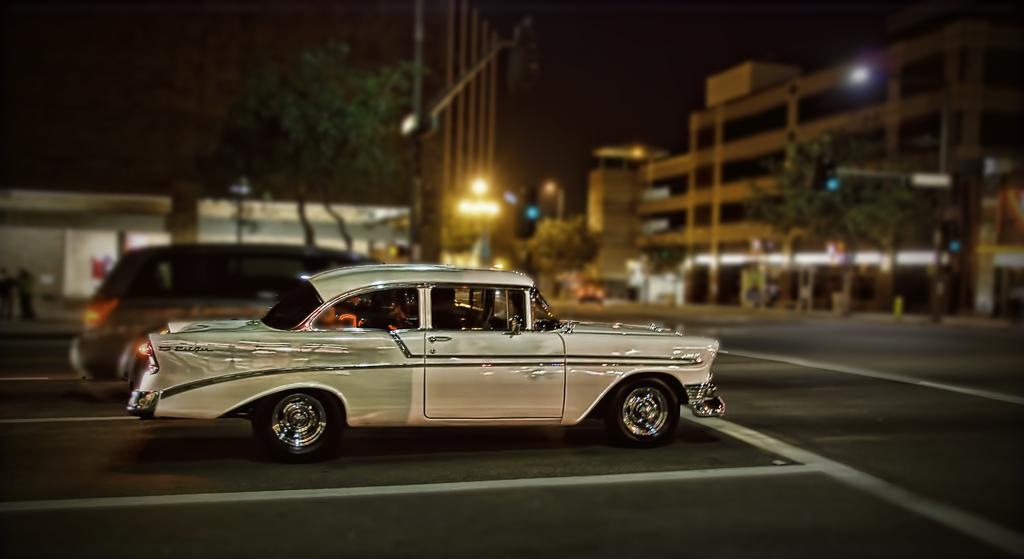What can be seen moving on the road in the image? There are vehicles on the road in the image. What type of structures are visible in the image? There are buildings in the image. What can be seen illuminating the scene in the image? There are lights in the image. What are the vertical structures in the image? There are poles in the image. What type of natural elements are present in the image? There are trees in the image. What type of produce is being sold at the faucet in the image? There is no produce or faucet present in the image. How does the sleet affect the visibility of the vehicles on the road in the image? There is no sleet present in the image, so its effect on visibility cannot be determined. 